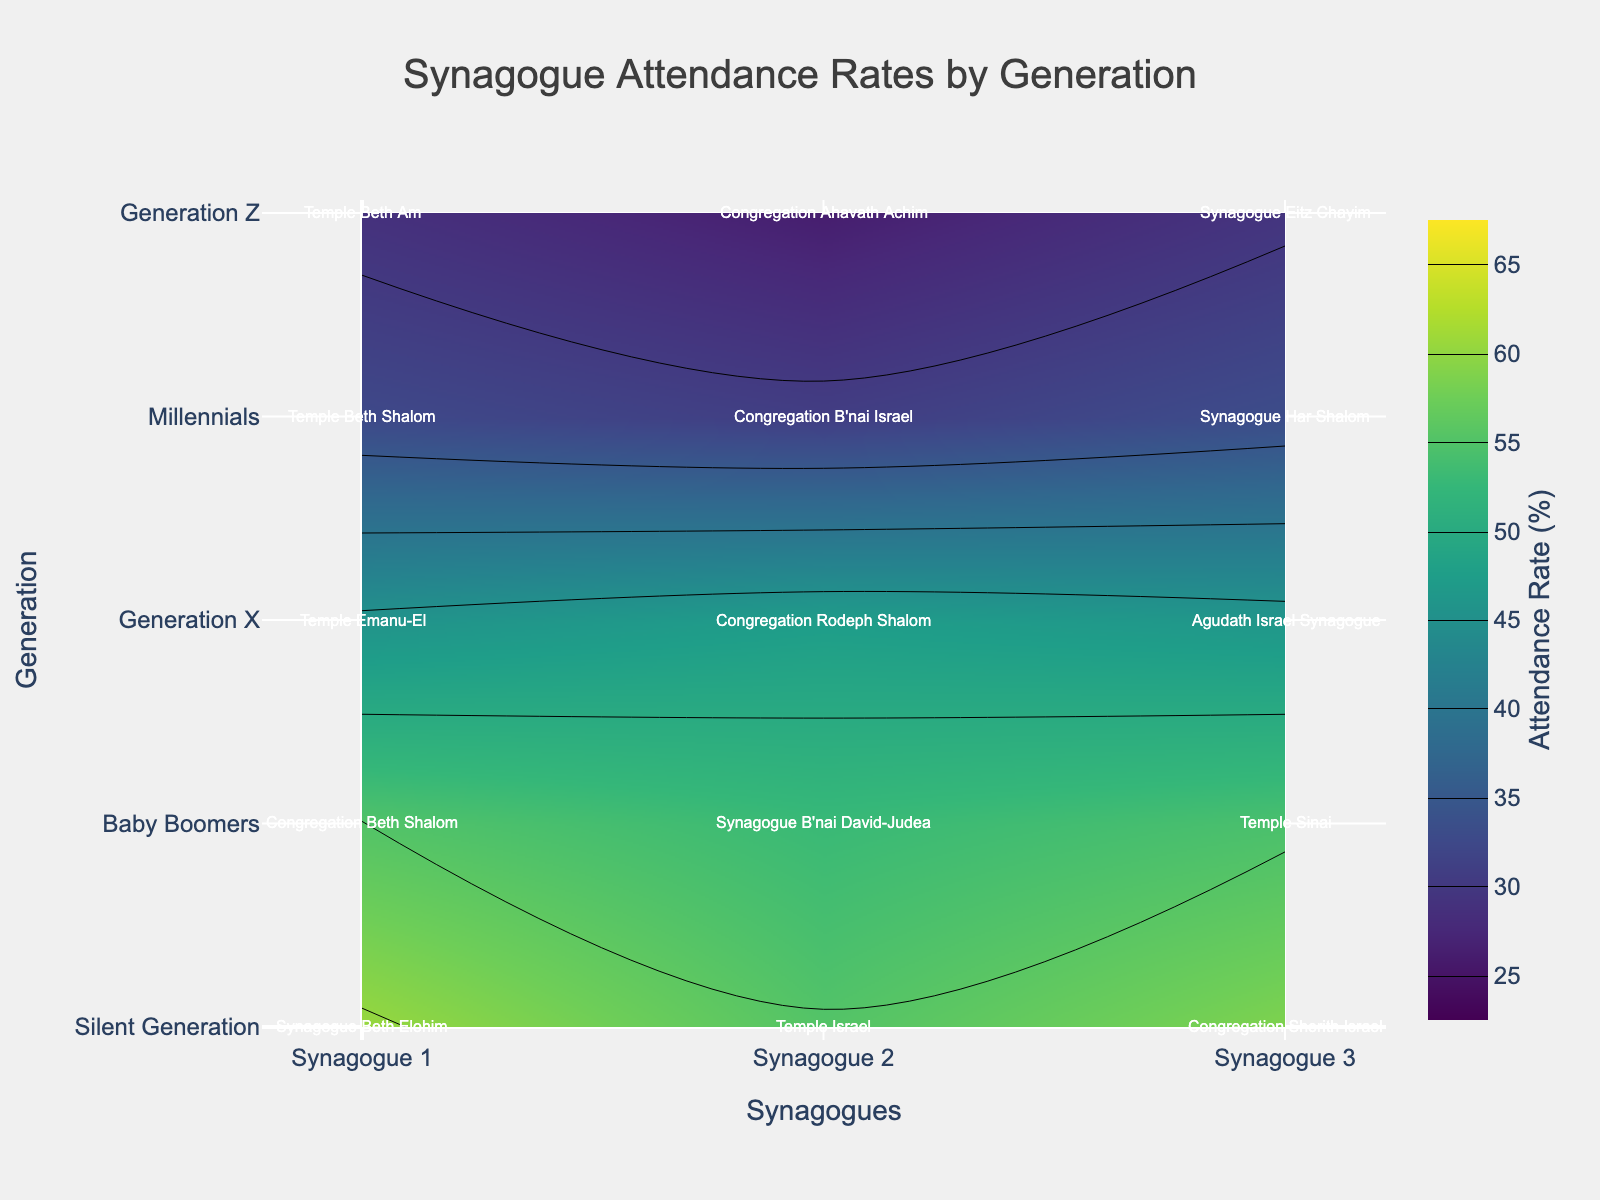Which generation has the highest average attendance rate? By looking at the y-axis labeled by generation and the highest contour lines, the Silent Generation shows the highest attendance rate in most synagogues.
Answer: Silent Generation What is the attendance rate range represented in the plot? The colorbar on the right side of the plot shows the attendance range. The contours span from 25% to 65%.
Answer: 25% to 65% Which synagogue from the Generation Z group has the highest attendance rate? By examining the Generation Z row (usually the bottom-most row), and reading off the annotations, Synagogue Eitz Chayim has the highest attendance rate among Generation Z.
Answer: Synagogue Eitz Chayim Compare the attendance rates between the Baby Boomers and Millennials groups. Who has a higher average rate? By checking y-axis positions corresponding to 'Baby Boomers' and 'Millennials' and comparing the overall heights of the contour lines in these rows, Baby Boomers have higher average attendance rates than Millennials.
Answer: Baby Boomers How does the attendance rate of Temple Emanu-El among Generation X compare to Temple Beth Shalom among Millennials? Locate the X-axis annotation for Temple Emanu-El on Generation X row and compare with the contour value of Temple Beth Shalom on the Millennials row. Temple Emanu-El has a higher attendance rate (around 45.6%) compared to Temple Beth Shalom (around 32.5%).
Answer: Temple Emanu-El is higher What is the difference between the highest and lowest attendance rates in the Silent Generation group? Silent Generation’s highest rate is at Synagogue Beth Elohim (60.5%) and the lowest at Temple Israel (55.2%). The difference is calculated as 60.5% - 55.2% = 5.3%.
Answer: 5.3% Identify the synagogue with the lowest attendance rate overall. By looking at all generations and finding the lowest-labeled contour value, Congregation Ahavath Achim in Generation Z has the lowest attendance rate (26.2%).
Answer: Congregation Ahavath Achim What trend can be observed as we move from Silent Generation to Generation Z in terms of synagogue attendance? By examining the plot from the top (Silent Generation) down to the bottom (Generation Z), a decreasing trend in synagogue attendance rates can be observed. Each younger generation has progressively lower attendance rates.
Answer: Decrease in attendance 